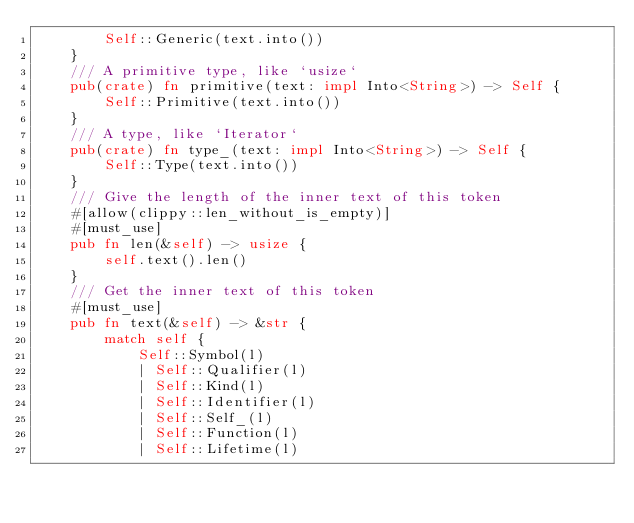<code> <loc_0><loc_0><loc_500><loc_500><_Rust_>        Self::Generic(text.into())
    }
    /// A primitive type, like `usize`
    pub(crate) fn primitive(text: impl Into<String>) -> Self {
        Self::Primitive(text.into())
    }
    /// A type, like `Iterator`
    pub(crate) fn type_(text: impl Into<String>) -> Self {
        Self::Type(text.into())
    }
    /// Give the length of the inner text of this token
    #[allow(clippy::len_without_is_empty)]
    #[must_use]
    pub fn len(&self) -> usize {
        self.text().len()
    }
    /// Get the inner text of this token
    #[must_use]
    pub fn text(&self) -> &str {
        match self {
            Self::Symbol(l)
            | Self::Qualifier(l)
            | Self::Kind(l)
            | Self::Identifier(l)
            | Self::Self_(l)
            | Self::Function(l)
            | Self::Lifetime(l)</code> 